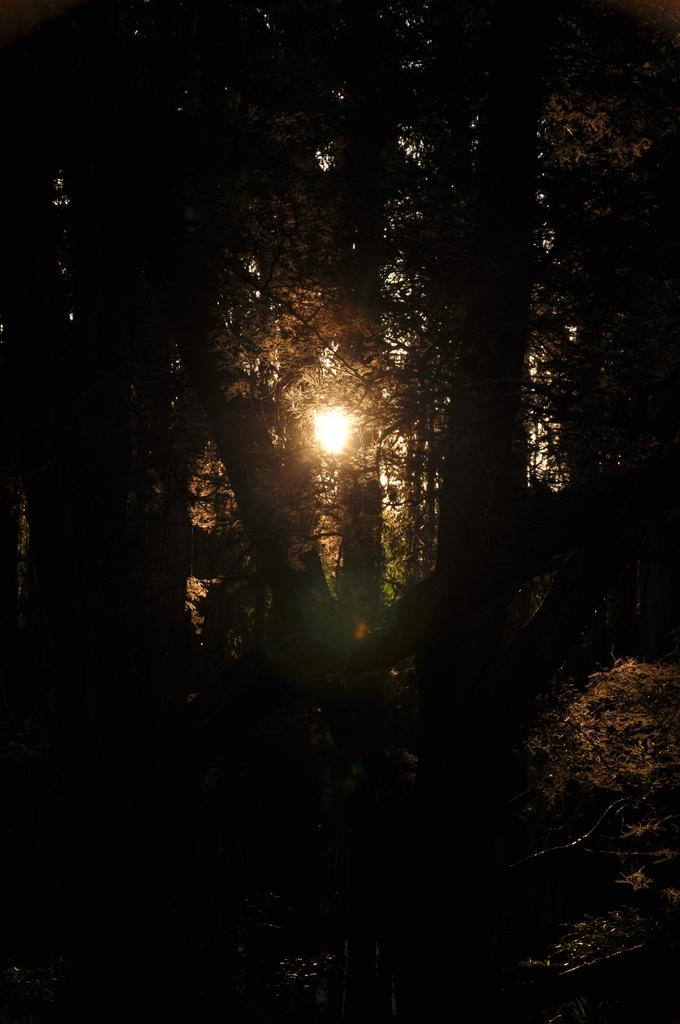What is the overall lighting condition of the image? The image is dark. What type of natural elements can be seen in the image? There are trees in the image. Is there any source of light visible in the image? Yes, there is a light visible through the trees. What type of hair can be seen on the trees in the image? There is no hair present in the image; it features trees and a light. 